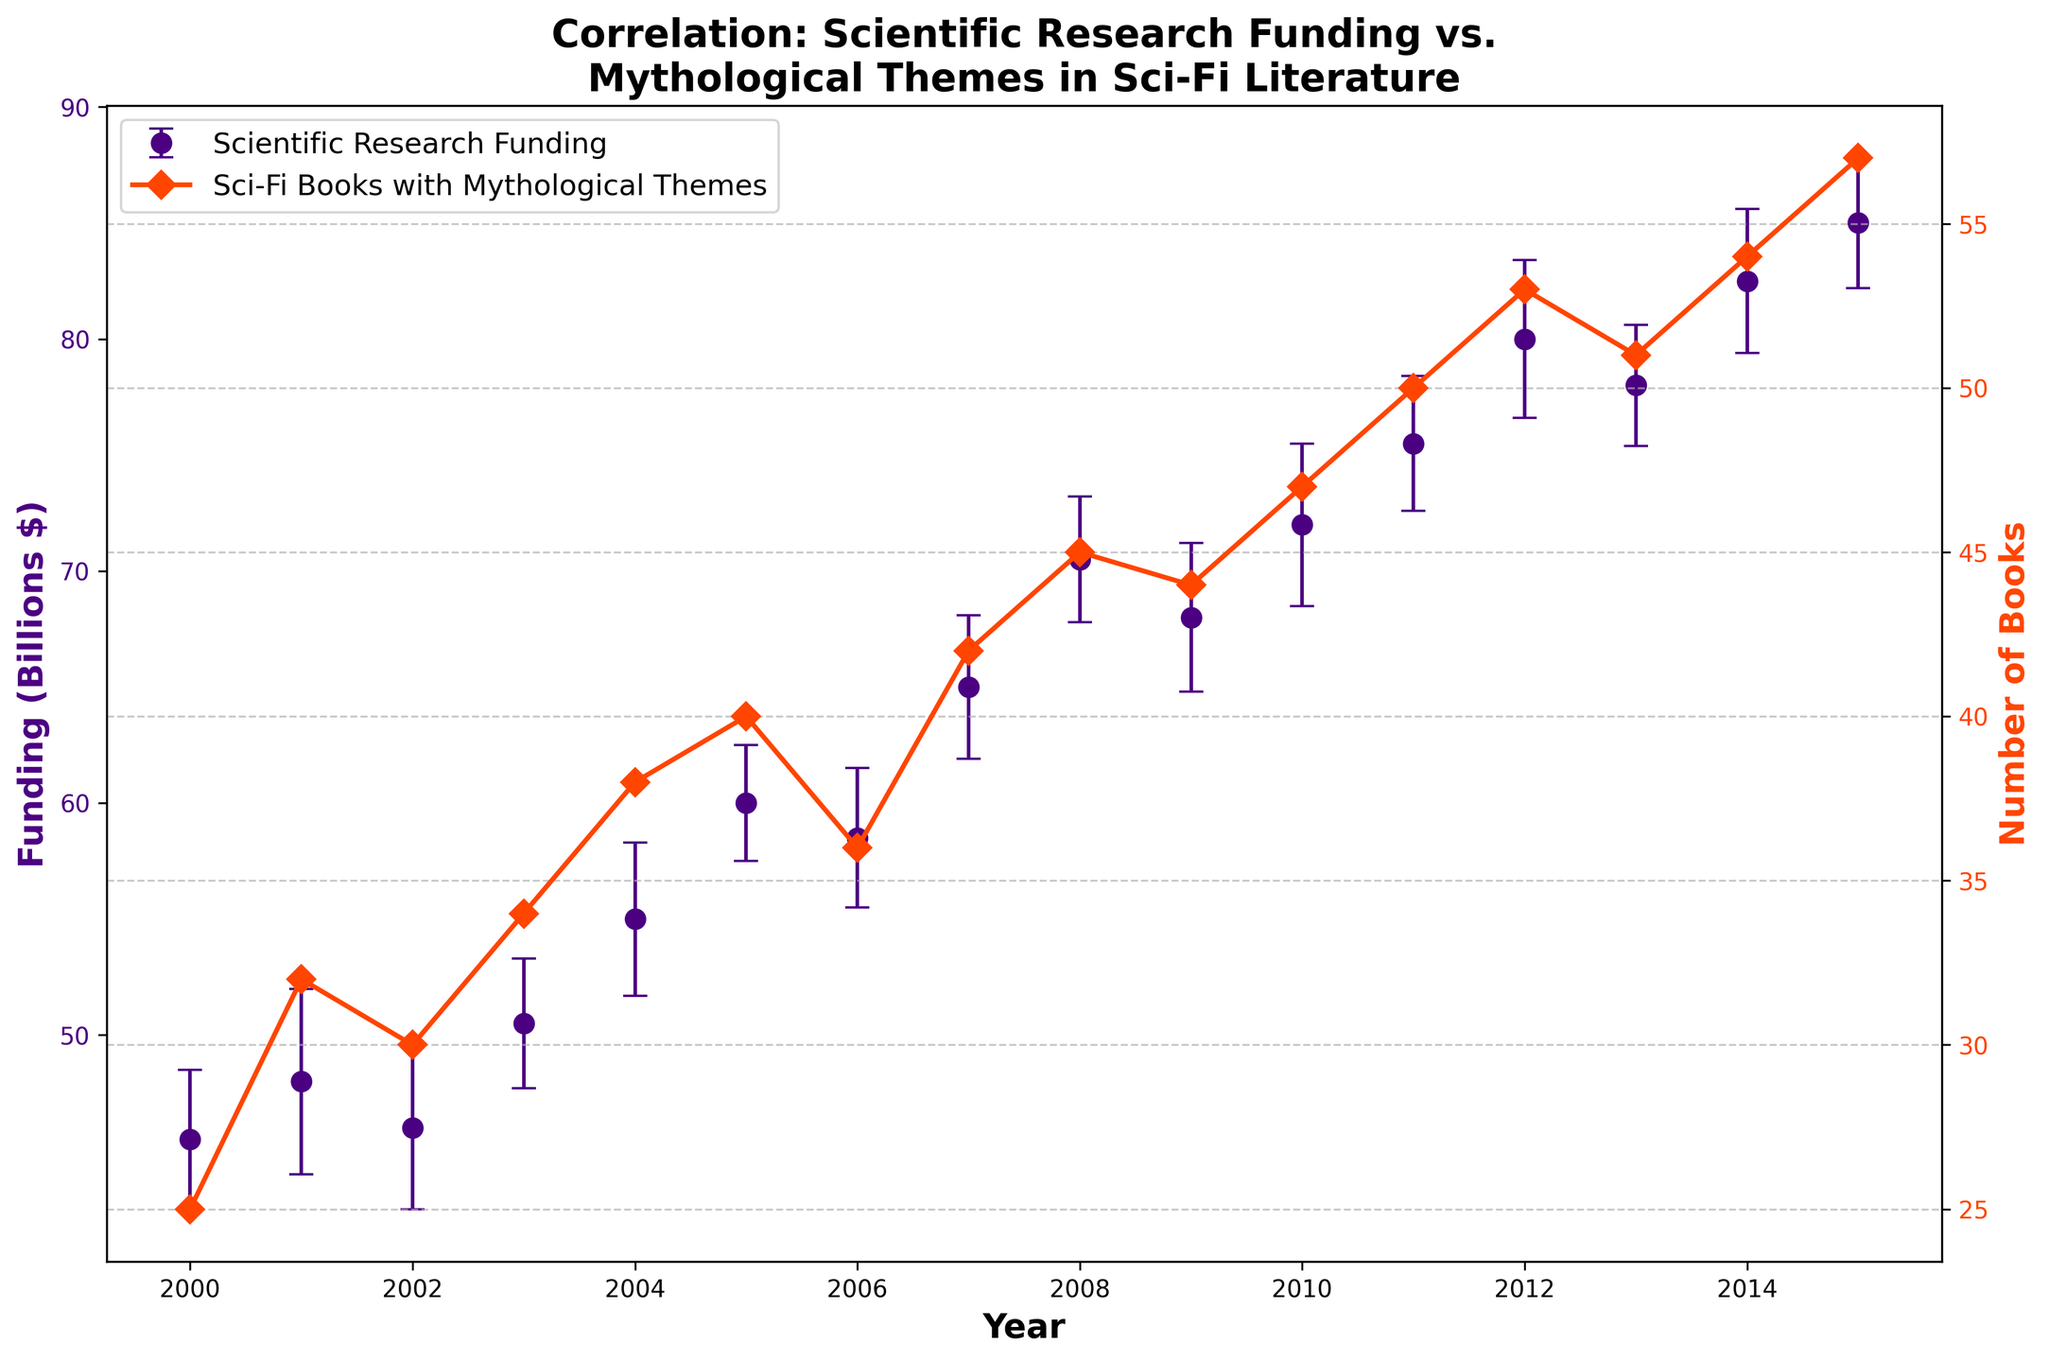What is the title of the figure? The title is displayed at the top of the figure. It reads "Correlation: Scientific Research Funding vs.\nMythological Themes in Sci-Fi Literature".
Answer: Correlation: Scientific Research Funding vs. Mythological Themes in Sci-Fi Literature What is the color of the error bars used to represent funding for scientific research? The error bars for funding for scientific research are shown in a color corresponding to the dot markers used for this dataset. The color used is indigo.
Answer: Indigo Which year had the highest funding for scientific research? By examining the vertical axis labeled "Funding (Billions $)" and corresponding dot values, the peak funding occurred in 2015.
Answer: 2015 How many Sci-Fi books with mythological themes were published in 2004? Refer to the curve labeled "Sci-Fi Books with Mythological Themes" and locate the year 2004 on the horizontal axis. The corresponding marker intersects the vertical axis at 38.
Answer: 38 What is the range of standard errors depicted for the funding data across all years? The standard error values for the funding data are listed in the table and vary between 2.5 and 4. Hence, the range is from 2.5 to 4.
Answer: 2.5 to 4 In which year did the number of Sci-Fi books with mythological themes decrease compared to the previous year? Observe the trend of the orange-red line representing the number of Sci-Fi books with mythological themes. The transition from the year 2012 to 2013 shows a slight decrease from 53 to 51.
Answer: 2013 What is the total increase in scientific research funding from 2000 to 2015? To find the total increase, subtract the funding value in 2000 (45.5 billion) from that in 2015 (85 billion). The result is 85 - 45.5 = 39.5 billion.
Answer: 39.5 billion Compare the number of Sci-Fi books published with mythological themes in 2005 and 2012. Which year had more publications? By referencing the orange-red line, in 2005, 40 books were published, and in 2012, 53 books were published. Clearly, 2012 had more publications than 2005.
Answer: 2012 Between which two consecutive years did scientific research funding see the largest increase? Examine the year-over-year increments in funding values. The largest increase can be seen between 2004 and 2005 (55.0 to 60.0 billion), a rise of 5 billion.
Answer: 2004-2005 What is the average funding for scientific research over the years 2000-2015? Sum the funding values from 2000 to 2015 and divide by the number of years. The total is (45.5 + 48.0 + 46.0 + 50.5 + 55.0 + 60.0 + 58.5 + 65.0 + 70.5 + 68.0 + 72.0 + 75.5 + 80.0 + 78.0 + 82.5 + 85.0) = 1010.5 billion. Dividing by 16, we get 1010.5 / 16 = 63.15625 billion.
Answer: 63.16 billion 